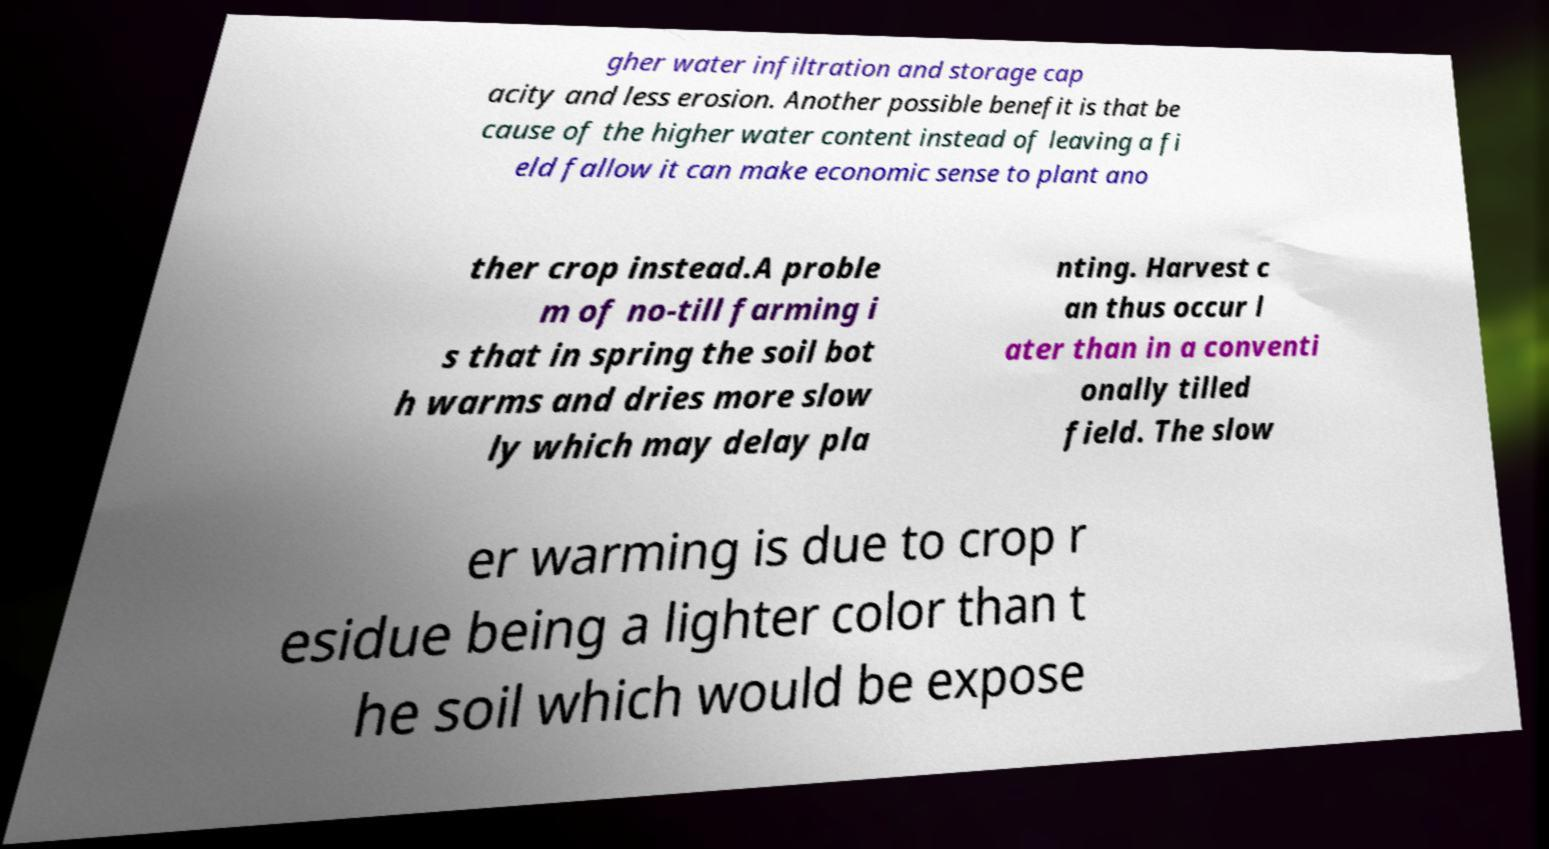Can you read and provide the text displayed in the image?This photo seems to have some interesting text. Can you extract and type it out for me? gher water infiltration and storage cap acity and less erosion. Another possible benefit is that be cause of the higher water content instead of leaving a fi eld fallow it can make economic sense to plant ano ther crop instead.A proble m of no-till farming i s that in spring the soil bot h warms and dries more slow ly which may delay pla nting. Harvest c an thus occur l ater than in a conventi onally tilled field. The slow er warming is due to crop r esidue being a lighter color than t he soil which would be expose 